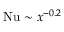Convert formula to latex. <formula><loc_0><loc_0><loc_500><loc_500>N u \sim x ^ { - 0 . 2 }</formula> 